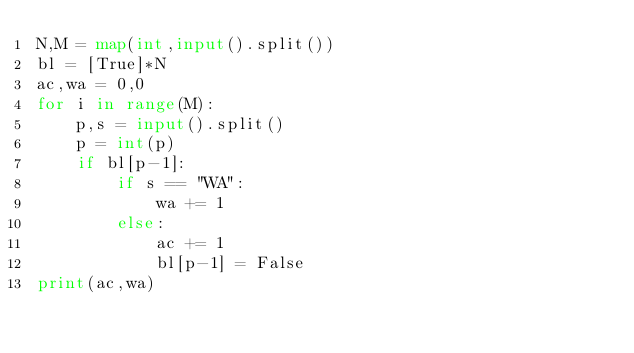Convert code to text. <code><loc_0><loc_0><loc_500><loc_500><_Python_>N,M = map(int,input().split())
bl = [True]*N
ac,wa = 0,0
for i in range(M):
    p,s = input().split()
    p = int(p)
    if bl[p-1]:
        if s == "WA":
            wa += 1
        else:
            ac += 1
            bl[p-1] = False
print(ac,wa)</code> 